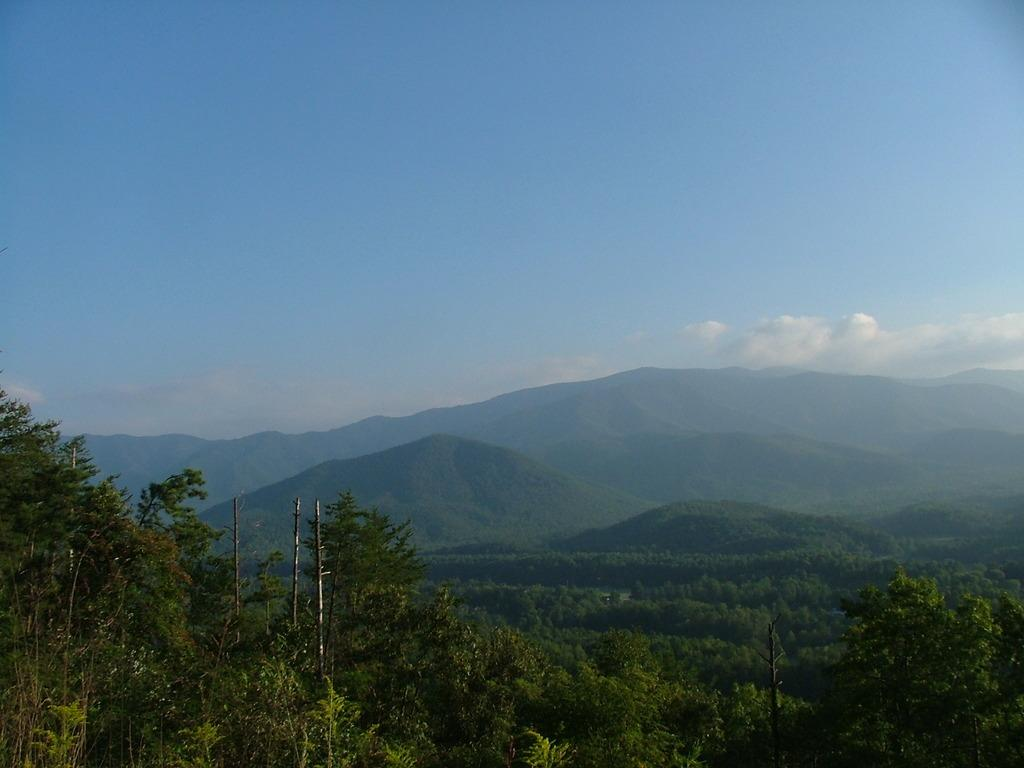What type of vegetation is present at the bottom of the image? There are trees at the bottom of the image. What is visible at the top of the image? The sky is visible at the top of the image. How many kittens are sitting on the knee of the person in the image? There is no person or kittens present in the image. 